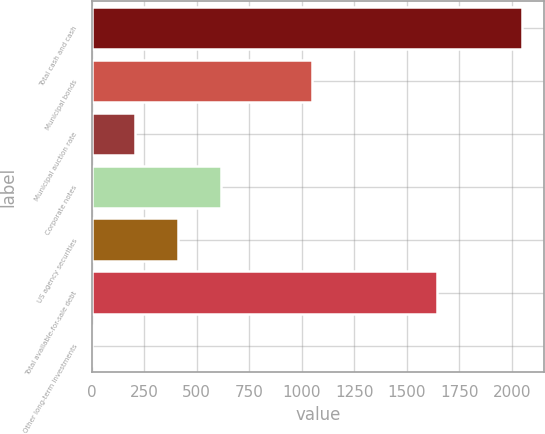Convert chart. <chart><loc_0><loc_0><loc_500><loc_500><bar_chart><fcel>Total cash and cash<fcel>Municipal bonds<fcel>Municipal auction rate<fcel>Corporate notes<fcel>US agency securities<fcel>Total available-for-sale debt<fcel>Other long-term investments<nl><fcel>2050<fcel>1050<fcel>208.6<fcel>617.8<fcel>413.2<fcel>1645<fcel>4<nl></chart> 